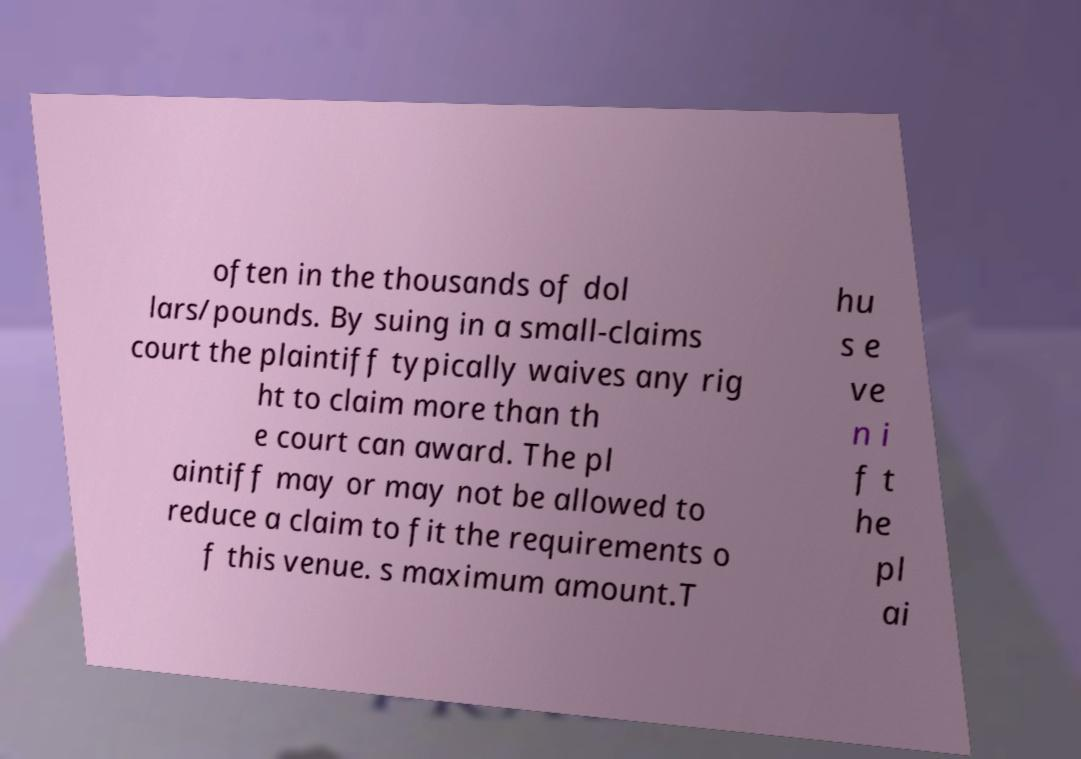For documentation purposes, I need the text within this image transcribed. Could you provide that? often in the thousands of dol lars/pounds. By suing in a small-claims court the plaintiff typically waives any rig ht to claim more than th e court can award. The pl aintiff may or may not be allowed to reduce a claim to fit the requirements o f this venue. s maximum amount.T hu s e ve n i f t he pl ai 